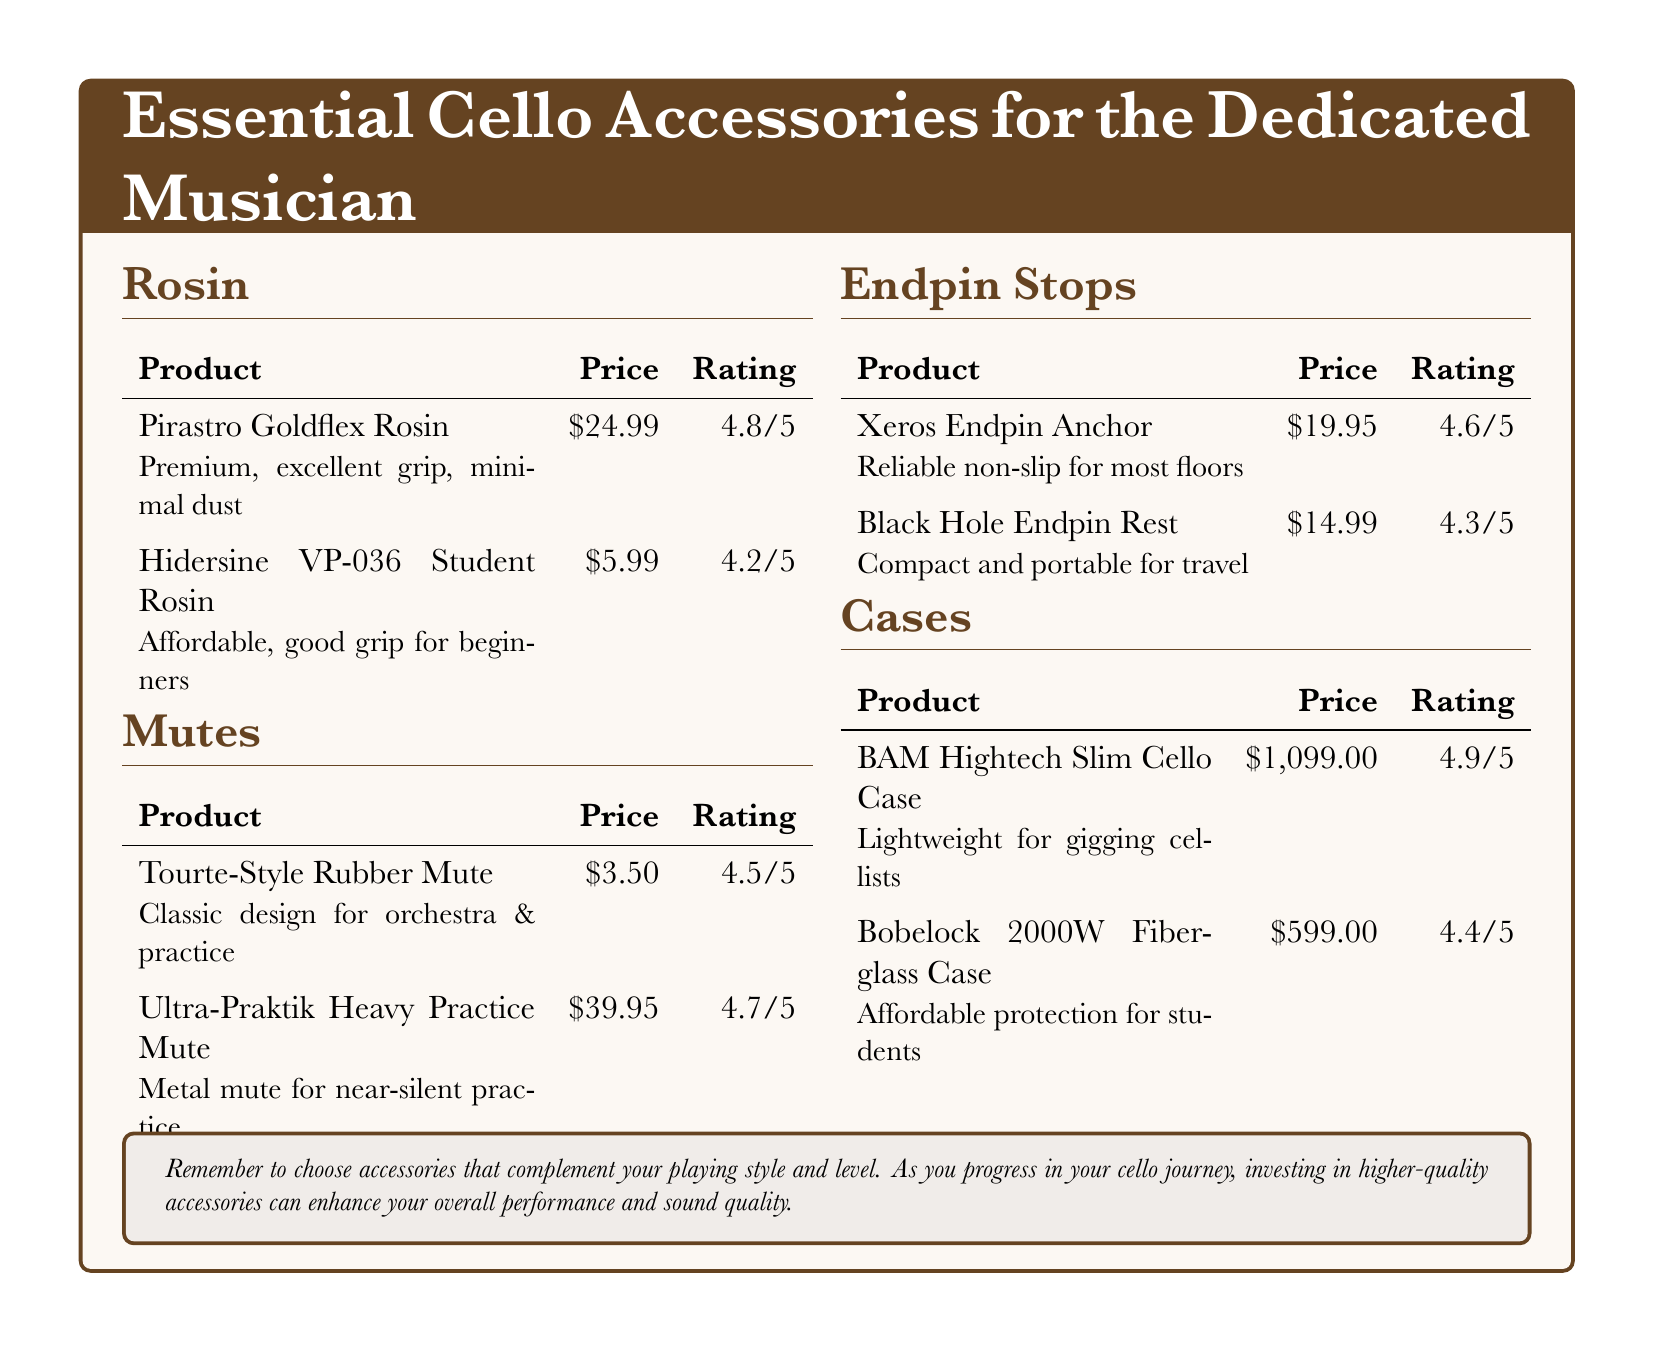What is the price of Pirastro Goldflex Rosin? The price is listed under the product section for rosin.
Answer: $24.99 How many stars is the rating for Ultra-Praktik Heavy Practice Mute? The rating is shown in the mutes section.
Answer: 4.7/5 Which endpin stop is described as portable for travel? The description is found in the endpin stops section.
Answer: Black Hole Endpin Rest What is the price of the BAM Hightech Slim Cello Case? The price can be found in the cases section.
Answer: $1,099.00 Which rosin is recommended for beginners? The recommendation is in the rosin section.
Answer: Hidersine VP-036 Student Rosin How does the Xeros Endpin Anchor rank? The ranking is indicated in the endpin stops section.
Answer: 4.6/5 What type of mute is the Tourte-Style Rubber Mute? The type is explained in the mutes section.
Answer: Classic design for orchestra & practice How much does the Bobelock 2000W Fiberglass Case cost? The price is listed in the cases section.
Answer: $599.00 